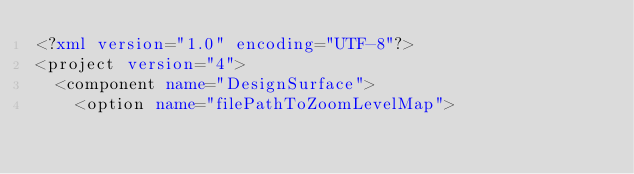<code> <loc_0><loc_0><loc_500><loc_500><_XML_><?xml version="1.0" encoding="UTF-8"?>
<project version="4">
  <component name="DesignSurface">
    <option name="filePathToZoomLevelMap"></code> 